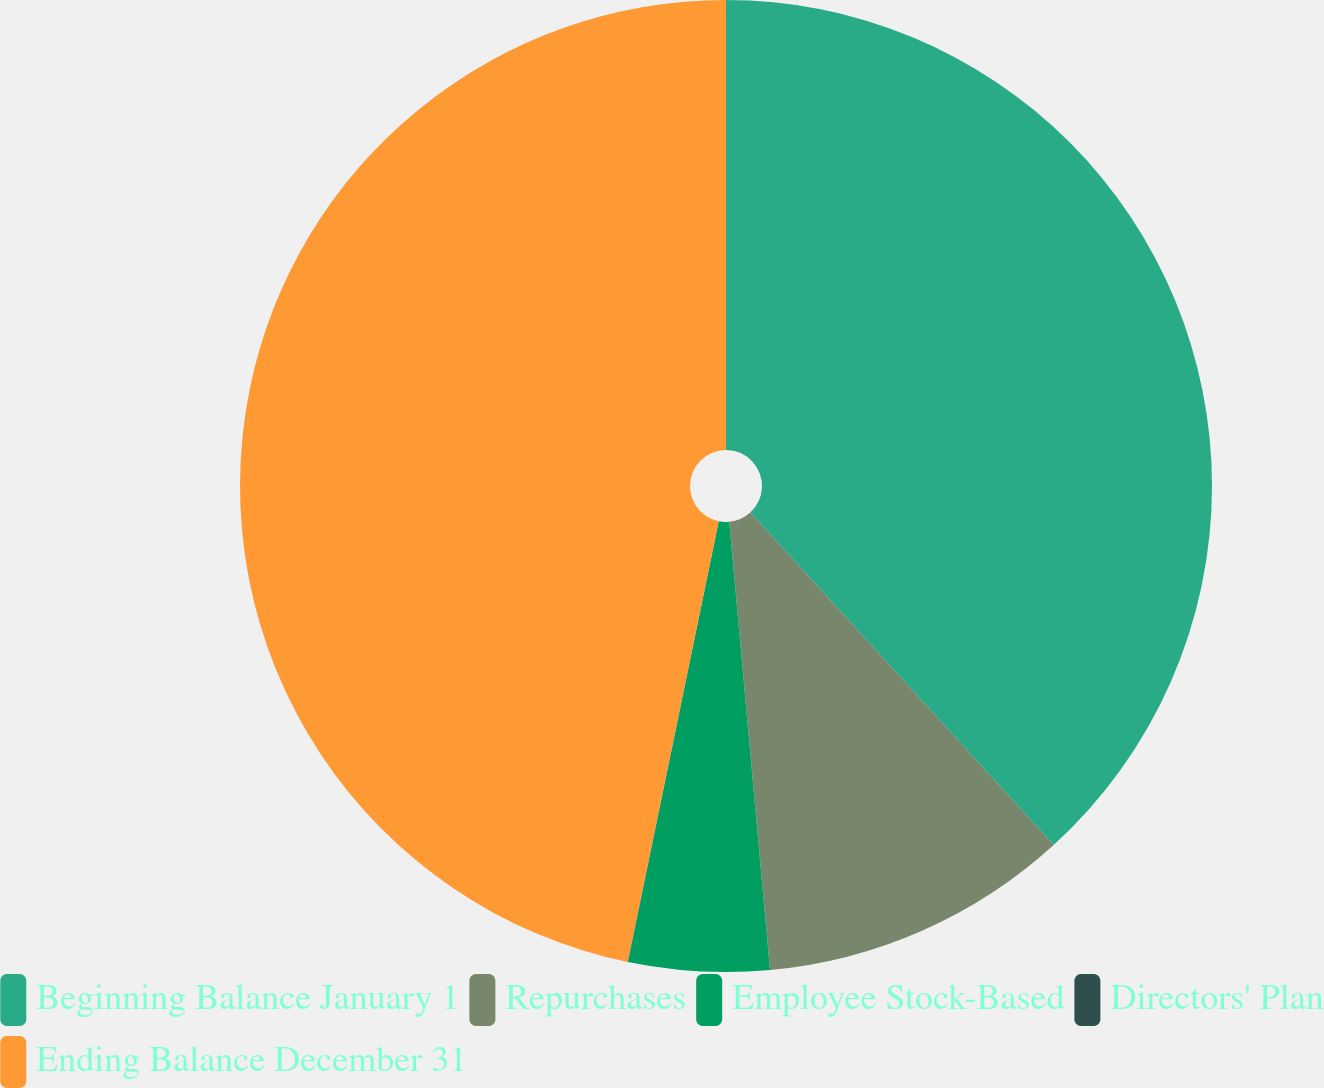Convert chart to OTSL. <chart><loc_0><loc_0><loc_500><loc_500><pie_chart><fcel>Beginning Balance January 1<fcel>Repurchases<fcel>Employee Stock-Based<fcel>Directors' Plan<fcel>Ending Balance December 31<nl><fcel>38.23%<fcel>10.33%<fcel>4.68%<fcel>0.01%<fcel>46.76%<nl></chart> 